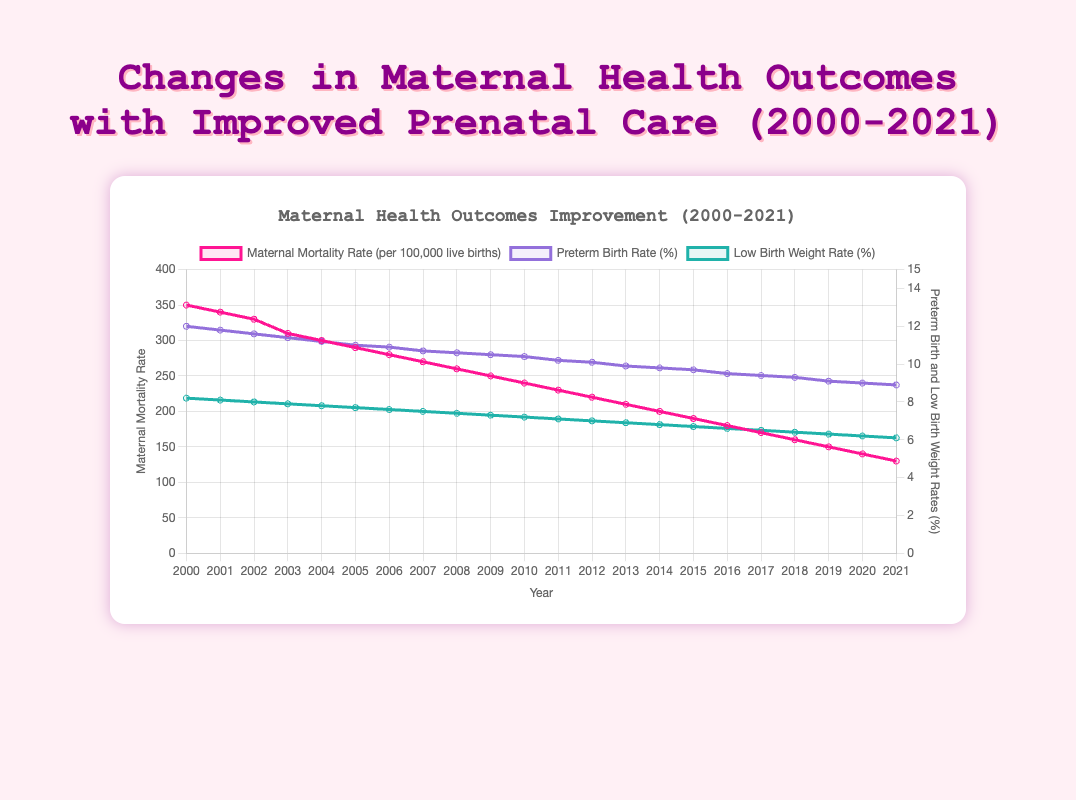What trend can be observed in the maternal mortality rate from 2000 to 2021? The figure shows a clear downward trend in the maternal mortality rate over the years. From 2000 to 2021, the rate consistently decreases each year. In 2000, the rate was around 350 per 100,000 live births, while by 2021, it dropped to approximately 130.
Answer: Decreasing trend How does the preterm birth rate in 2000 compare to the rate in 2021? In 2000, the preterm birth rate was around 12.0%, while in 2021, it decreased to approximately 8.9%. This shows an improvement in prenatal care over the given period.
Answer: Lower in 2021 Which year shows the greatest single-year drop in maternal mortality rate? To find the largest single-year drop, subtract each year’s rate from the previous year’s rate. The greatest drop is between 2002 and 2003, where the rate declined from 330 to 310, which is a drop of 20.
Answer: 2003 What is the overall reduction in low birth weight rate from 2000 to 2021? In 2000, the low birth weight rate was 8.2%, and in 2021, it was 6.1%. The reduction is calculated by subtracting the 2021 rate from the 2000 rate: 8.2% - 6.1% = 2.1%.
Answer: 2.1% Which health outcome showed the most substantial overall improvement between 2000 and 2021? By comparing the reductions: Maternal mortality rate dropped from 350 to 130 (a decrease of 220). Preterm birth rate dropped from 12.0% to 8.9% (a decrease of 3.1%). Low birth weight rate dropped from 8.2% to 6.1% (a decrease of 2.1%). The maternal mortality rate has the most substantial overall improvement.
Answer: Maternal mortality rate By how many years did it take for the maternal mortality rate to decrease from 350 to 230? The maternal mortality rate decreased from 350 in 2000 to 230 in 2011. The number of years is calculated as 2011 - 2000 = 11 years.
Answer: 11 years What can be said about the trend in preterm birth rates and low birth weight rates from 2000 to 2021 based on their visual lines? Both the preterm birth and low birth weight rates show a downward trend over the period. Their respective lines indicate a consistent decrease, suggesting improved prenatal care over the years.
Answer: Decreasing trend Compare the maternal mortality rate and low birth weight rate trends between 2015 and 2020. From 2015 to 2020, the maternal mortality rate decreased from 190 to 140, and the low birth weight rate decreased from 6.7% to 6.2%. Both show a downward trend over this period, though the decrease in maternal mortality is more pronounced.
Answer: Both decreased In which year did the preterm birth rate first drop below 10%? The preterm birth rate first dropped below 10% in the year 2013, where it was recorded at 9.9%.
Answer: 2013 What visual difference is observed between maternal mortality rate and preterm birth rate in terms of the chart's axis alignment? The maternal mortality rate is aligned with the left y-axis, labeled specifically for it, while the preterm birth rate, along with low birth weight rate, is aligned with the right y-axis. This dual-axis arrangement visually separates the two types of data for clarity.
Answer: Different y-axes 